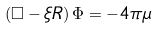<formula> <loc_0><loc_0><loc_500><loc_500>\left ( \Box - \xi R \right ) \Phi = - 4 \pi \mu</formula> 